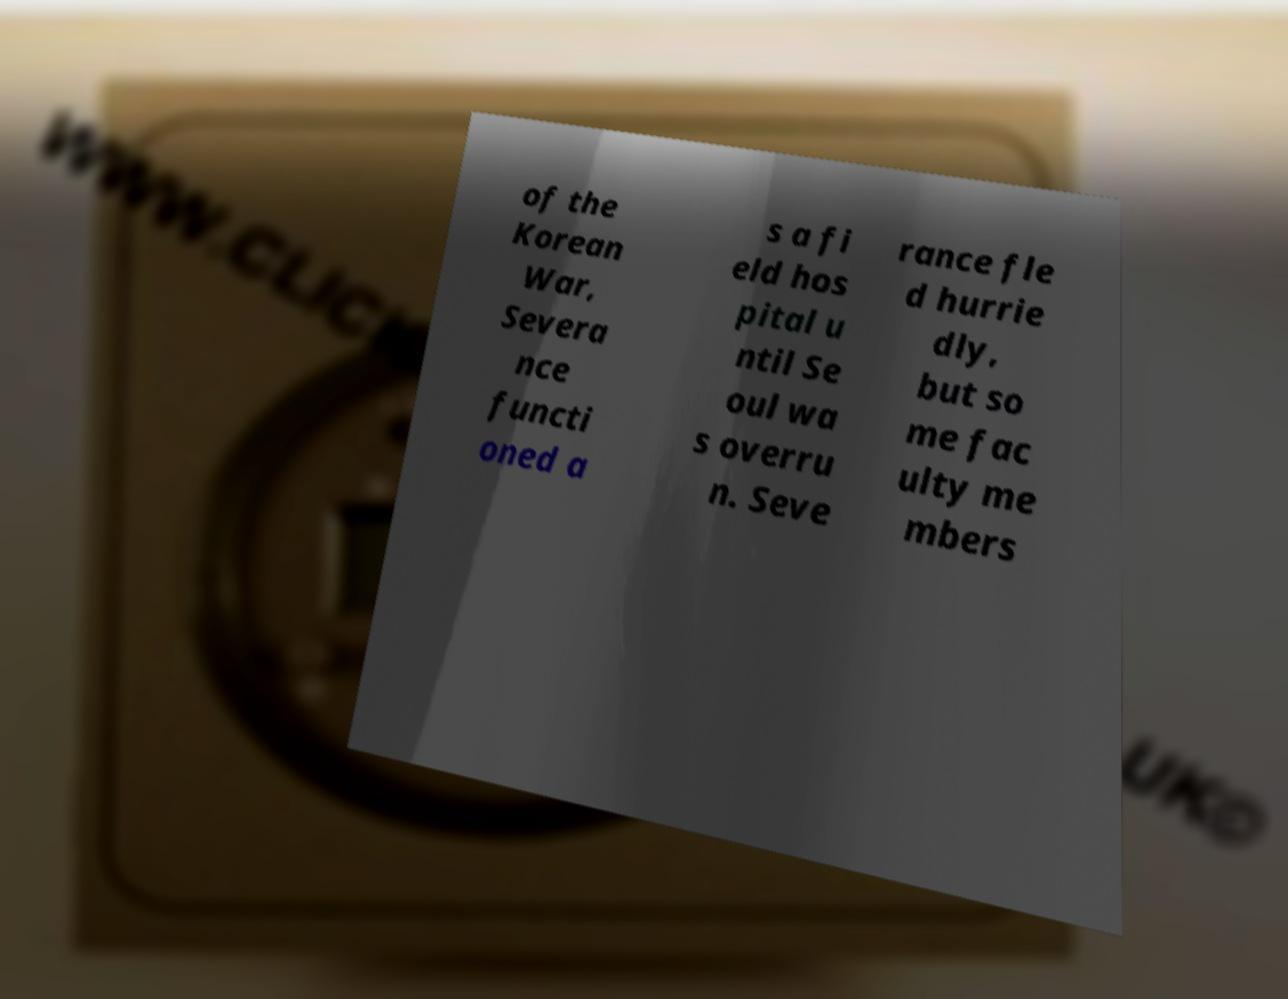Could you assist in decoding the text presented in this image and type it out clearly? of the Korean War, Severa nce functi oned a s a fi eld hos pital u ntil Se oul wa s overru n. Seve rance fle d hurrie dly, but so me fac ulty me mbers 